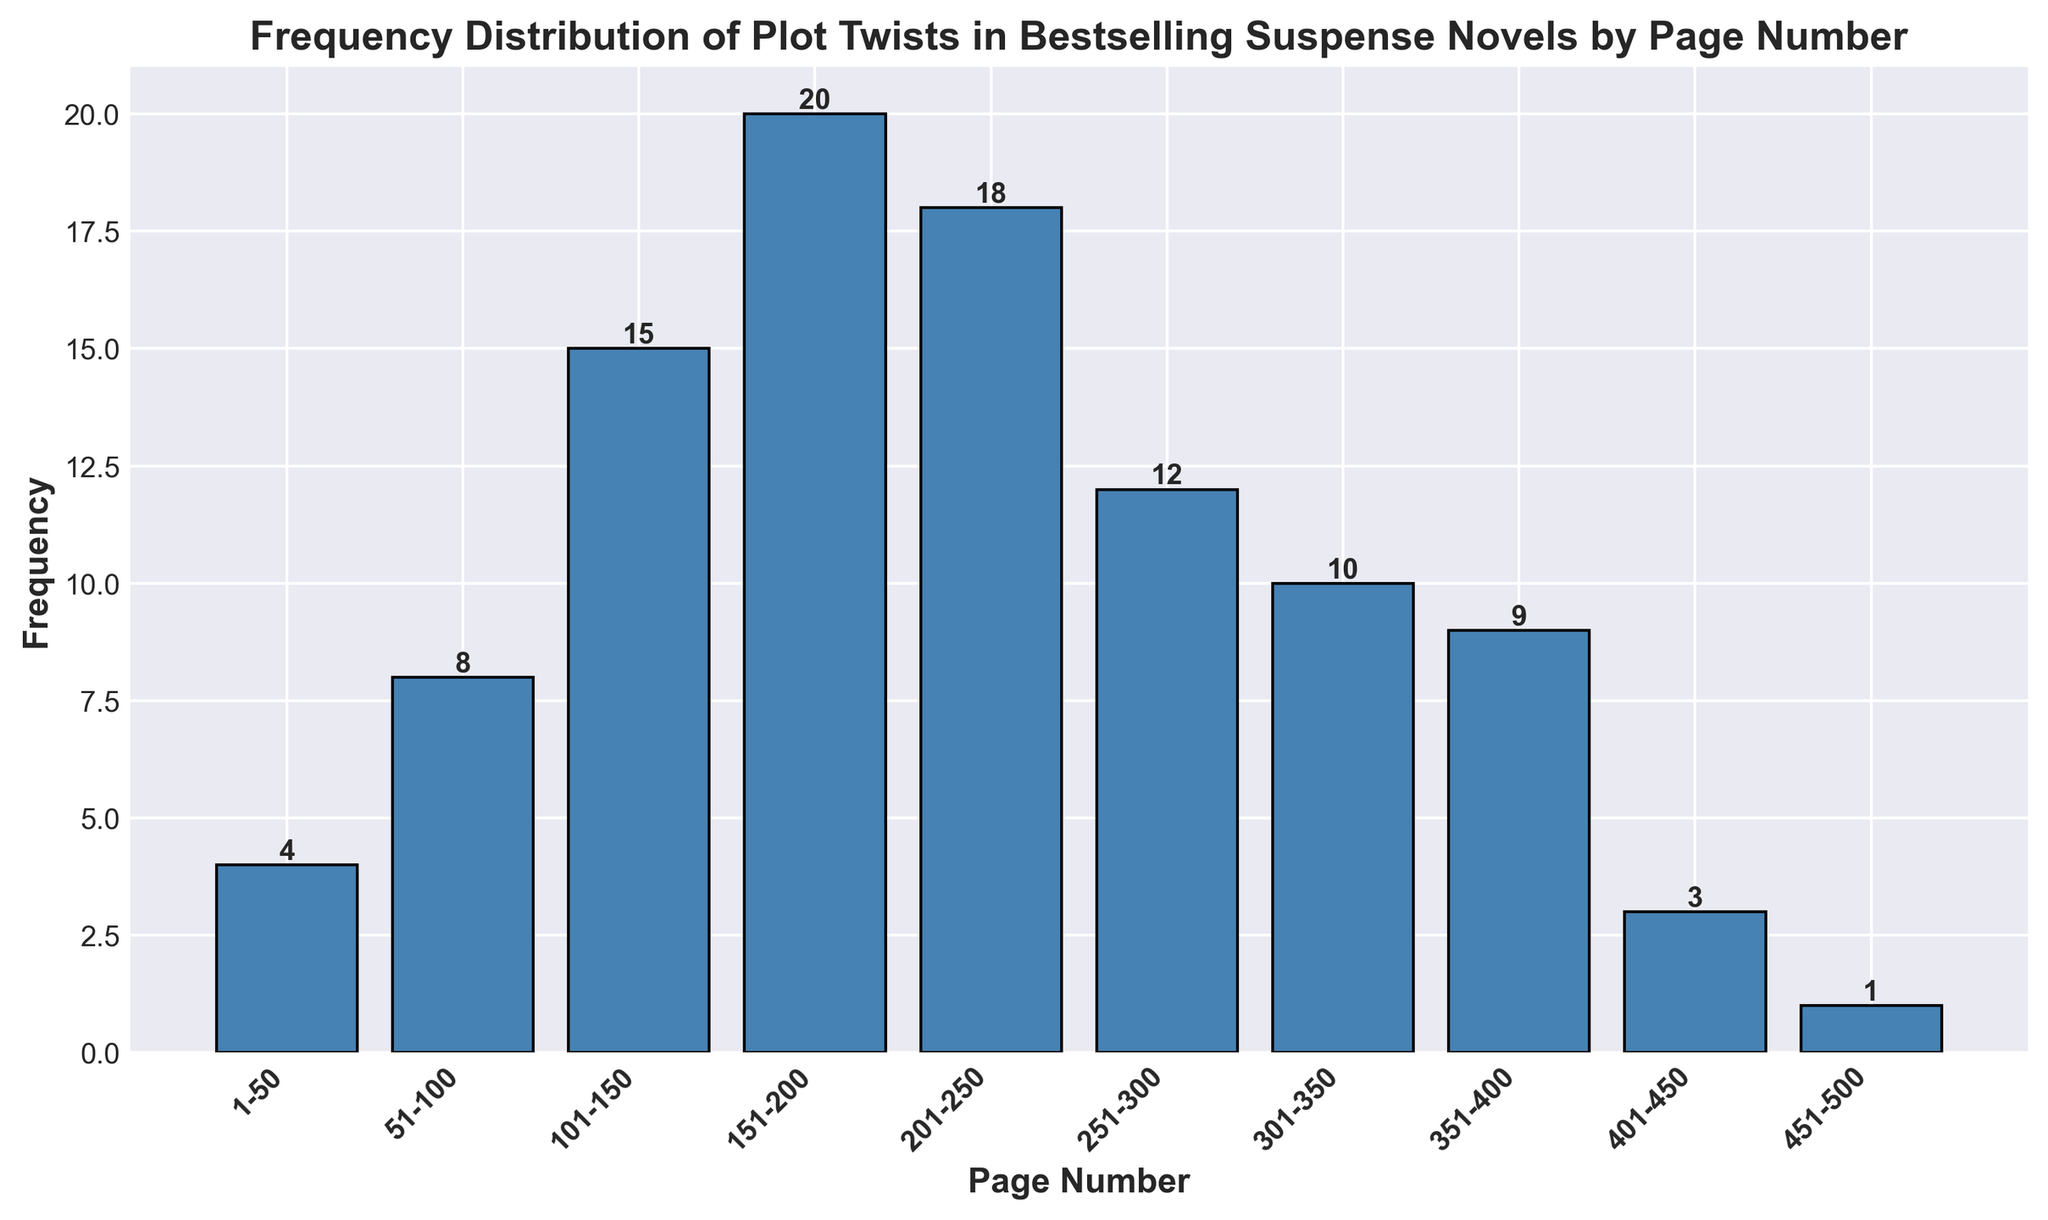What is the total frequency of plot twists occurring between pages 151 and 250? To find the total frequency of plot twists between pages 151 and 250, sum the frequencies for the ranges 151-200 and 201-250: 20 (151-200) + 18 (201-250) = 38
Answer: 38 Which page range has the highest frequency of plot twists? The bar with the highest value represents the page range 151-200 with a frequency of 20, making it the one with the highest frequency of plot twists.
Answer: 151-200 How many plot twists occur after page 300? To find the total number of plot twists after page 300, sum the frequencies for the ranges 301-350, 351-400, 401-450, and 451-500: 10 (301-350) + 9 (351-400) + 3 (401-450) + 1 (451-500) = 23
Answer: 23 What is the difference in the frequency of plot twists between the page range 51-100 and 301-350? To find the difference, subtract the frequency of the range 301-350 from the frequency of the range 51-100: 8 (51-100) - 10 (301-350) = -2
Answer: -2 What is the average frequency of plot twists in the first 200 pages? Sum the frequencies of the ranges 1-50, 51-100, 101-150, and 151-200 and then divide by 4: (4 + 8 + 15 + 20) / 4 = 11.75
Answer: 11.75 Which page range has a lower frequency of plot twists: 1-50 or 451-500? Comparing the two page ranges, the frequency for 1-50 is 4 and for 451-500 is 1, so 451-500 has a lower frequency.
Answer: 451-500 How does the frequency of plot twists between 201-250 compare to that between 251-300? The frequency of plot twists between 201-250 is 18, while for 251-300 it is 12. Therefore, 201-250 has a higher frequency.
Answer: 18 > 12 What is the combined frequency of plot twists in the ranges 101-150 and 301-350? Add the frequencies of the ranges 101-150 and 301-350: 15 (101-150) + 10 (301-350) = 25
Answer: 25 How much higher is the frequency of plot twists in the range 151-200 compared to the range 1-50? Subtract the frequency of 1-50 from the frequency of 151-200: 20 (151-200) - 4 (1-50) = 16
Answer: 16 What visual cues help identify the page range with the least plot twists? The height of the bars in the histogram represents the frequency. The shortest bar corresponds to the page range 451-500, indicating it has the least frequency of plot twists.
Answer: 451-500 